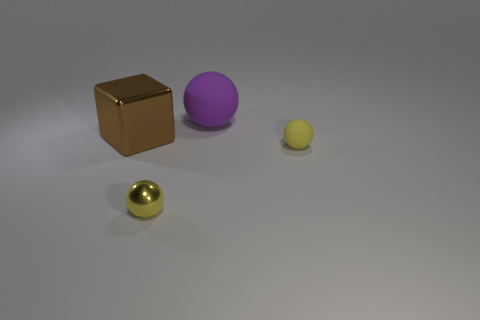What is the shape of the object that is the same size as the purple rubber ball?
Your answer should be very brief. Cube. There is a large thing that is behind the large brown thing to the left of the small yellow rubber ball; are there any large matte balls that are in front of it?
Make the answer very short. No. There is a small thing that is to the right of the small metal sphere; does it have the same color as the large matte sphere?
Ensure brevity in your answer.  No. What number of cylinders are brown metallic things or big rubber objects?
Provide a short and direct response. 0. There is a metal object on the left side of the small yellow thing that is in front of the tiny yellow rubber ball; what shape is it?
Make the answer very short. Cube. What size is the yellow thing that is to the right of the yellow ball left of the small yellow ball that is right of the big ball?
Offer a terse response. Small. Is the size of the yellow metallic object the same as the brown metallic thing?
Offer a terse response. No. How many things are either large cyan cylinders or large brown metal things?
Your response must be concise. 1. How big is the yellow thing behind the yellow thing to the left of the purple matte object?
Offer a terse response. Small. What size is the purple thing?
Your answer should be compact. Large. 